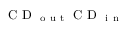Convert formula to latex. <formula><loc_0><loc_0><loc_500><loc_500>C D _ { o u t } C D _ { i n }</formula> 